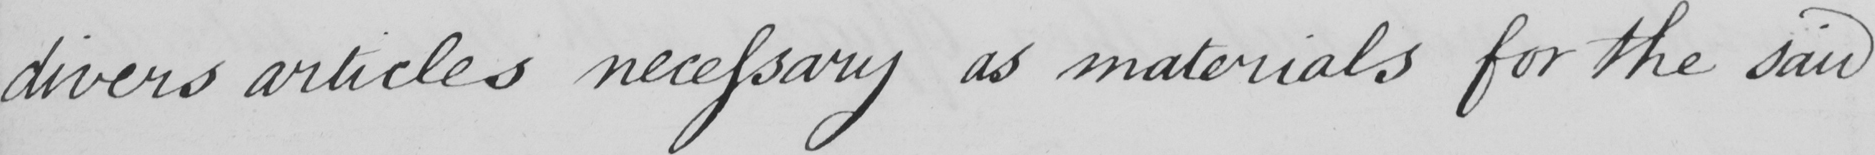What text is written in this handwritten line? divers articles necessary as materials for the said 